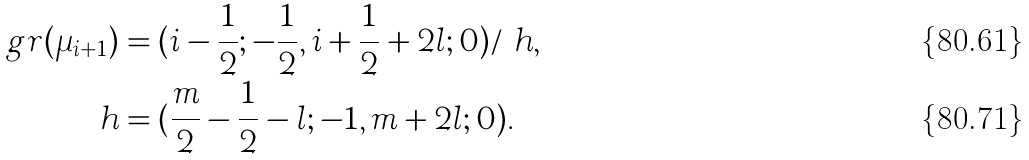<formula> <loc_0><loc_0><loc_500><loc_500>g r ( \mu _ { i + 1 } ) & = ( i - \frac { 1 } { 2 } ; - \frac { 1 } { 2 } , i + \frac { 1 } { 2 } + 2 l ; 0 ) / \ h , \\ h & = ( \frac { m } { 2 } - \frac { 1 } { 2 } - l ; - 1 , m + 2 l ; 0 ) .</formula> 